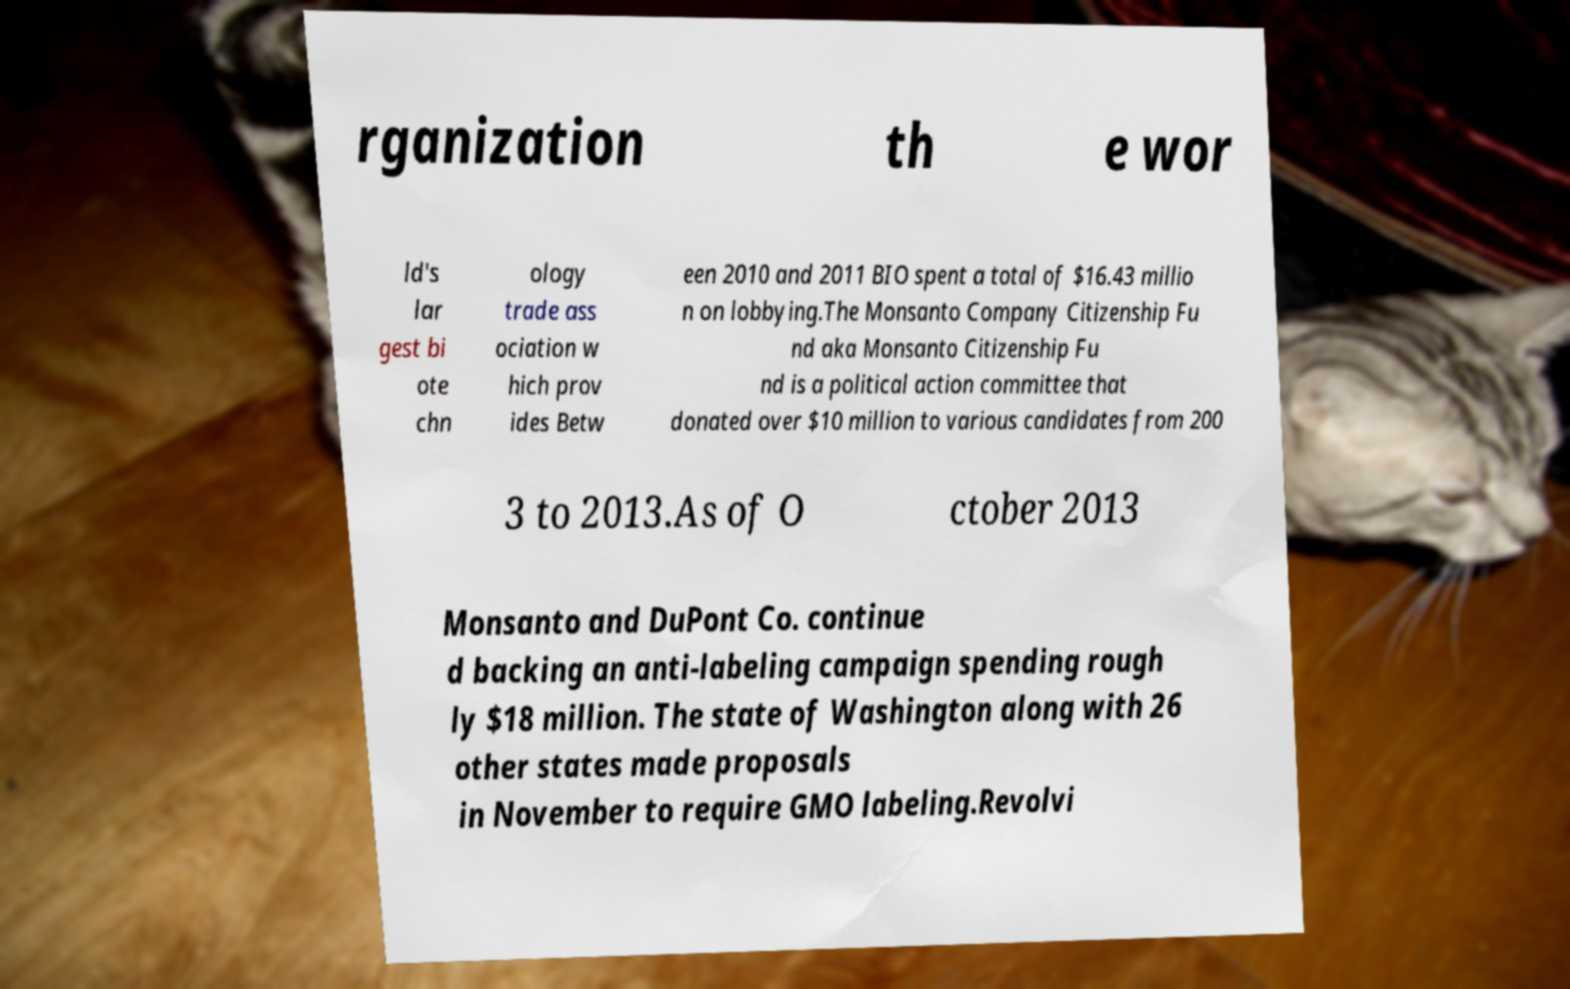There's text embedded in this image that I need extracted. Can you transcribe it verbatim? rganization th e wor ld's lar gest bi ote chn ology trade ass ociation w hich prov ides Betw een 2010 and 2011 BIO spent a total of $16.43 millio n on lobbying.The Monsanto Company Citizenship Fu nd aka Monsanto Citizenship Fu nd is a political action committee that donated over $10 million to various candidates from 200 3 to 2013.As of O ctober 2013 Monsanto and DuPont Co. continue d backing an anti-labeling campaign spending rough ly $18 million. The state of Washington along with 26 other states made proposals in November to require GMO labeling.Revolvi 